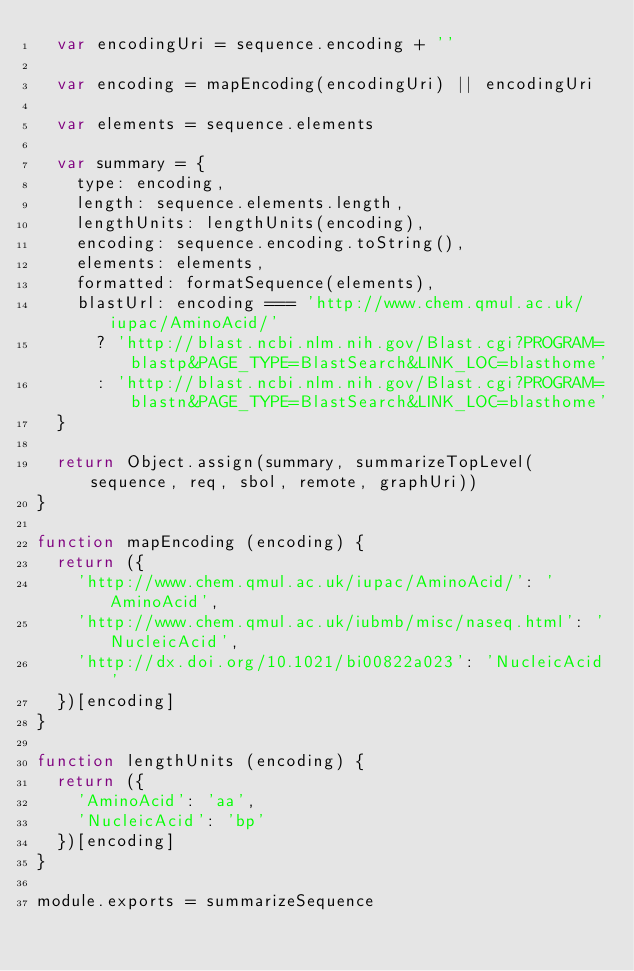Convert code to text. <code><loc_0><loc_0><loc_500><loc_500><_JavaScript_>  var encodingUri = sequence.encoding + ''

  var encoding = mapEncoding(encodingUri) || encodingUri

  var elements = sequence.elements

  var summary = {
    type: encoding,
    length: sequence.elements.length,
    lengthUnits: lengthUnits(encoding),
    encoding: sequence.encoding.toString(),
    elements: elements,
    formatted: formatSequence(elements),
    blastUrl: encoding === 'http://www.chem.qmul.ac.uk/iupac/AminoAcid/'
      ? 'http://blast.ncbi.nlm.nih.gov/Blast.cgi?PROGRAM=blastp&PAGE_TYPE=BlastSearch&LINK_LOC=blasthome'
      : 'http://blast.ncbi.nlm.nih.gov/Blast.cgi?PROGRAM=blastn&PAGE_TYPE=BlastSearch&LINK_LOC=blasthome'
  }

  return Object.assign(summary, summarizeTopLevel(sequence, req, sbol, remote, graphUri))
}

function mapEncoding (encoding) {
  return ({
    'http://www.chem.qmul.ac.uk/iupac/AminoAcid/': 'AminoAcid',
    'http://www.chem.qmul.ac.uk/iubmb/misc/naseq.html': 'NucleicAcid',
    'http://dx.doi.org/10.1021/bi00822a023': 'NucleicAcid'
  })[encoding]
}

function lengthUnits (encoding) {
  return ({
    'AminoAcid': 'aa',
    'NucleicAcid': 'bp'
  })[encoding]
}

module.exports = summarizeSequence
</code> 